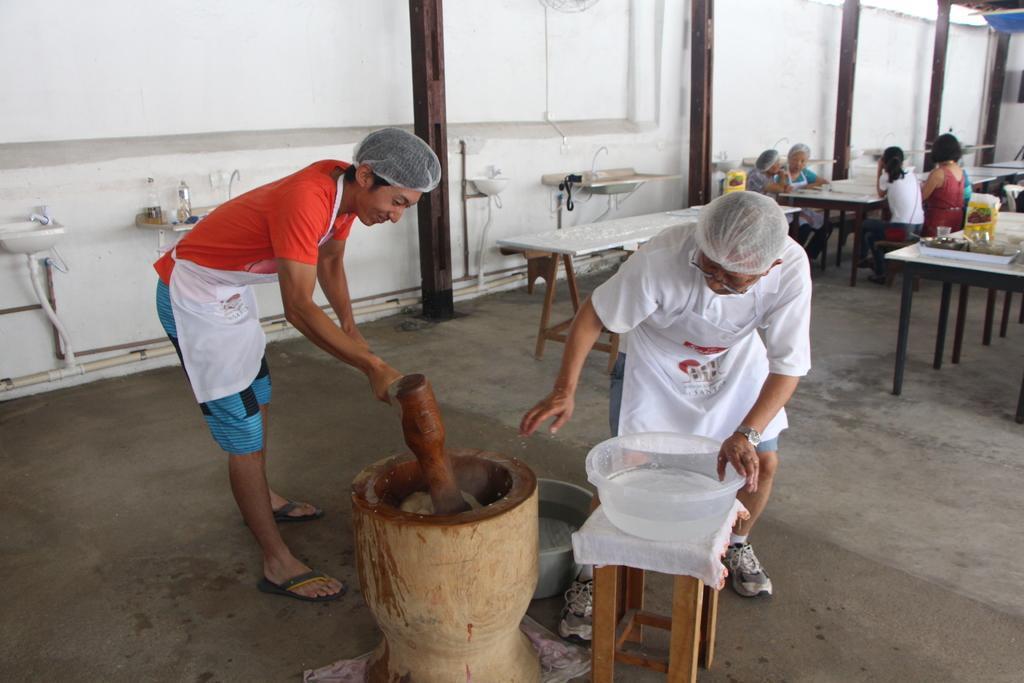How would you summarize this image in a sentence or two? In this image there are group of persons sitting at the right side of the image and at the middle of the image there are two person who are doing some work. 